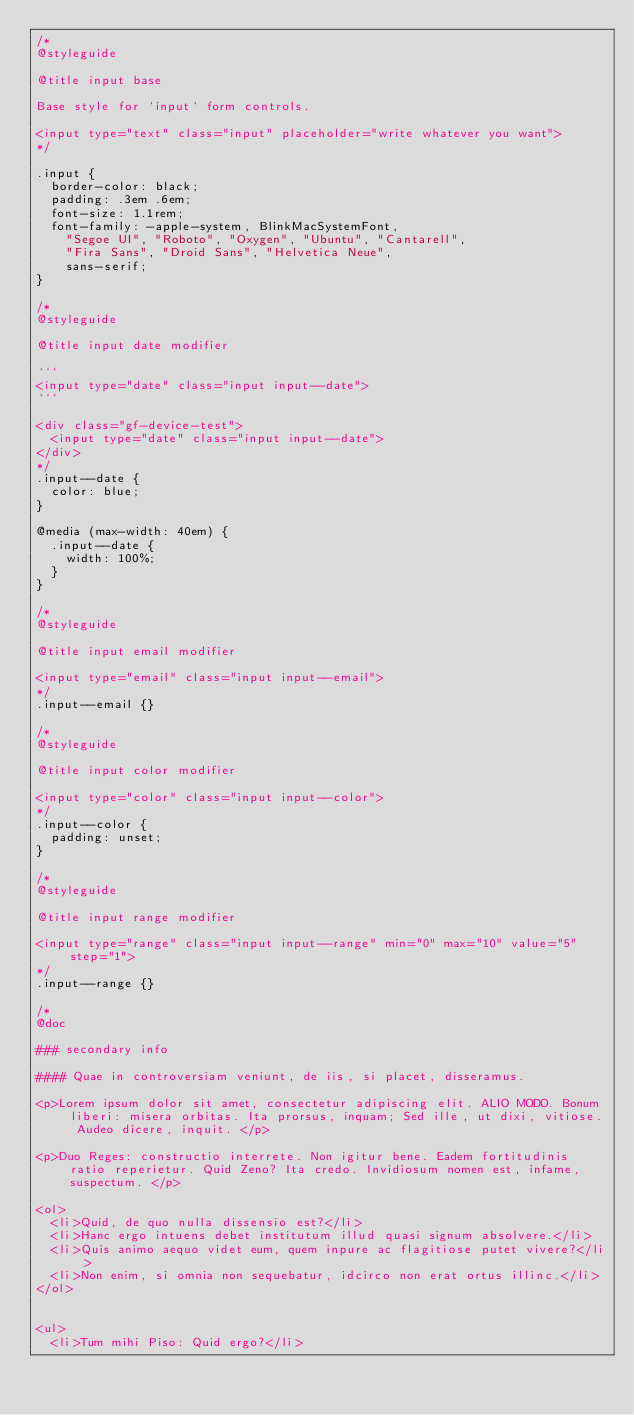<code> <loc_0><loc_0><loc_500><loc_500><_CSS_>/*
@styleguide

@title input base

Base style for `input` form controls.

<input type="text" class="input" placeholder="write whatever you want">
*/

.input {
  border-color: black;
  padding: .3em .6em;
  font-size: 1.1rem;
  font-family: -apple-system, BlinkMacSystemFont,
    "Segoe UI", "Roboto", "Oxygen", "Ubuntu", "Cantarell",
    "Fira Sans", "Droid Sans", "Helvetica Neue",
    sans-serif;
}

/*
@styleguide

@title input date modifier

```
<input type="date" class="input input--date">
```

<div class="gf-device-test">
  <input type="date" class="input input--date">
</div>
*/
.input--date {
  color: blue;
}

@media (max-width: 40em) {
  .input--date {
    width: 100%;
  }
}

/*
@styleguide

@title input email modifier

<input type="email" class="input input--email">
*/
.input--email {}

/*
@styleguide

@title input color modifier

<input type="color" class="input input--color">
*/
.input--color {
  padding: unset;
}

/*
@styleguide

@title input range modifier

<input type="range" class="input input--range" min="0" max="10" value="5" step="1">
*/
.input--range {}

/*
@doc

### secondary info

#### Quae in controversiam veniunt, de iis, si placet, disseramus.

<p>Lorem ipsum dolor sit amet, consectetur adipiscing elit. ALIO MODO. Bonum liberi: misera orbitas. Ita prorsus, inquam; Sed ille, ut dixi, vitiose. Audeo dicere, inquit. </p>

<p>Duo Reges: constructio interrete. Non igitur bene. Eadem fortitudinis ratio reperietur. Quid Zeno? Ita credo. Invidiosum nomen est, infame, suspectum. </p>

<ol>
  <li>Quid, de quo nulla dissensio est?</li>
  <li>Hanc ergo intuens debet institutum illud quasi signum absolvere.</li>
  <li>Quis animo aequo videt eum, quem inpure ac flagitiose putet vivere?</li>
  <li>Non enim, si omnia non sequebatur, idcirco non erat ortus illinc.</li>
</ol>


<ul>
  <li>Tum mihi Piso: Quid ergo?</li></code> 